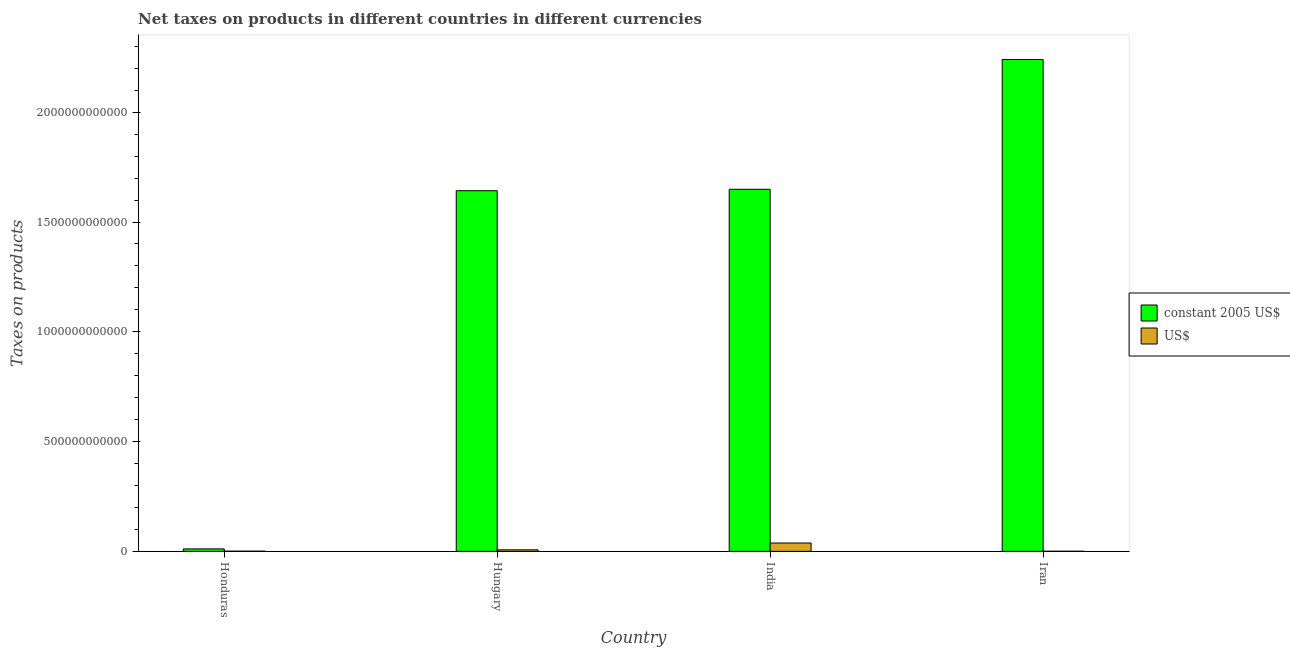How many bars are there on the 2nd tick from the left?
Your answer should be very brief. 2. What is the label of the 2nd group of bars from the left?
Provide a short and direct response. Hungary. What is the net taxes in constant 2005 us$ in Honduras?
Give a very brief answer. 1.12e+1. Across all countries, what is the maximum net taxes in us$?
Provide a short and direct response. 3.81e+1. Across all countries, what is the minimum net taxes in constant 2005 us$?
Offer a terse response. 1.12e+1. In which country was the net taxes in constant 2005 us$ maximum?
Give a very brief answer. Iran. In which country was the net taxes in us$ minimum?
Your answer should be compact. Iran. What is the total net taxes in us$ in the graph?
Your answer should be compact. 4.63e+1. What is the difference between the net taxes in us$ in India and that in Iran?
Offer a very short reply. 3.75e+1. What is the difference between the net taxes in us$ in Iran and the net taxes in constant 2005 us$ in Hungary?
Your response must be concise. -1.64e+12. What is the average net taxes in constant 2005 us$ per country?
Keep it short and to the point. 1.39e+12. What is the difference between the net taxes in us$ and net taxes in constant 2005 us$ in Iran?
Your response must be concise. -2.24e+12. What is the ratio of the net taxes in us$ in Hungary to that in India?
Offer a terse response. 0.18. Is the net taxes in us$ in Honduras less than that in Hungary?
Keep it short and to the point. Yes. What is the difference between the highest and the second highest net taxes in constant 2005 us$?
Offer a very short reply. 5.91e+11. What is the difference between the highest and the lowest net taxes in us$?
Make the answer very short. 3.75e+1. In how many countries, is the net taxes in us$ greater than the average net taxes in us$ taken over all countries?
Provide a succinct answer. 1. What does the 1st bar from the left in Iran represents?
Provide a short and direct response. Constant 2005 us$. What does the 2nd bar from the right in Honduras represents?
Ensure brevity in your answer.  Constant 2005 us$. Are all the bars in the graph horizontal?
Your response must be concise. No. What is the difference between two consecutive major ticks on the Y-axis?
Give a very brief answer. 5.00e+11. Are the values on the major ticks of Y-axis written in scientific E-notation?
Your response must be concise. No. Does the graph contain any zero values?
Offer a terse response. No. Where does the legend appear in the graph?
Offer a terse response. Center right. How many legend labels are there?
Your response must be concise. 2. How are the legend labels stacked?
Keep it short and to the point. Vertical. What is the title of the graph?
Make the answer very short. Net taxes on products in different countries in different currencies. What is the label or title of the X-axis?
Offer a terse response. Country. What is the label or title of the Y-axis?
Your response must be concise. Taxes on products. What is the Taxes on products of constant 2005 US$ in Honduras?
Your answer should be very brief. 1.12e+1. What is the Taxes on products of US$ in Honduras?
Provide a short and direct response. 7.81e+08. What is the Taxes on products in constant 2005 US$ in Hungary?
Offer a very short reply. 1.64e+12. What is the Taxes on products in US$ in Hungary?
Provide a succinct answer. 6.93e+09. What is the Taxes on products of constant 2005 US$ in India?
Your answer should be very brief. 1.65e+12. What is the Taxes on products of US$ in India?
Keep it short and to the point. 3.81e+1. What is the Taxes on products of constant 2005 US$ in Iran?
Keep it short and to the point. 2.24e+12. What is the Taxes on products in US$ in Iran?
Your answer should be compact. 5.37e+08. Across all countries, what is the maximum Taxes on products of constant 2005 US$?
Your answer should be very brief. 2.24e+12. Across all countries, what is the maximum Taxes on products of US$?
Provide a succinct answer. 3.81e+1. Across all countries, what is the minimum Taxes on products of constant 2005 US$?
Keep it short and to the point. 1.12e+1. Across all countries, what is the minimum Taxes on products of US$?
Your answer should be compact. 5.37e+08. What is the total Taxes on products in constant 2005 US$ in the graph?
Provide a succinct answer. 5.54e+12. What is the total Taxes on products of US$ in the graph?
Keep it short and to the point. 4.63e+1. What is the difference between the Taxes on products of constant 2005 US$ in Honduras and that in Hungary?
Keep it short and to the point. -1.63e+12. What is the difference between the Taxes on products in US$ in Honduras and that in Hungary?
Make the answer very short. -6.15e+09. What is the difference between the Taxes on products of constant 2005 US$ in Honduras and that in India?
Make the answer very short. -1.64e+12. What is the difference between the Taxes on products of US$ in Honduras and that in India?
Give a very brief answer. -3.73e+1. What is the difference between the Taxes on products of constant 2005 US$ in Honduras and that in Iran?
Provide a succinct answer. -2.23e+12. What is the difference between the Taxes on products of US$ in Honduras and that in Iran?
Your answer should be compact. 2.44e+08. What is the difference between the Taxes on products in constant 2005 US$ in Hungary and that in India?
Ensure brevity in your answer.  -6.62e+09. What is the difference between the Taxes on products of US$ in Hungary and that in India?
Your answer should be compact. -3.11e+1. What is the difference between the Taxes on products of constant 2005 US$ in Hungary and that in Iran?
Your answer should be compact. -5.98e+11. What is the difference between the Taxes on products of US$ in Hungary and that in Iran?
Offer a very short reply. 6.39e+09. What is the difference between the Taxes on products in constant 2005 US$ in India and that in Iran?
Make the answer very short. -5.91e+11. What is the difference between the Taxes on products in US$ in India and that in Iran?
Provide a succinct answer. 3.75e+1. What is the difference between the Taxes on products in constant 2005 US$ in Honduras and the Taxes on products in US$ in Hungary?
Your response must be concise. 4.29e+09. What is the difference between the Taxes on products in constant 2005 US$ in Honduras and the Taxes on products in US$ in India?
Your answer should be very brief. -2.68e+1. What is the difference between the Taxes on products in constant 2005 US$ in Honduras and the Taxes on products in US$ in Iran?
Give a very brief answer. 1.07e+1. What is the difference between the Taxes on products of constant 2005 US$ in Hungary and the Taxes on products of US$ in India?
Ensure brevity in your answer.  1.60e+12. What is the difference between the Taxes on products in constant 2005 US$ in Hungary and the Taxes on products in US$ in Iran?
Ensure brevity in your answer.  1.64e+12. What is the difference between the Taxes on products in constant 2005 US$ in India and the Taxes on products in US$ in Iran?
Your response must be concise. 1.65e+12. What is the average Taxes on products in constant 2005 US$ per country?
Your answer should be very brief. 1.39e+12. What is the average Taxes on products in US$ per country?
Keep it short and to the point. 1.16e+1. What is the difference between the Taxes on products of constant 2005 US$ and Taxes on products of US$ in Honduras?
Give a very brief answer. 1.04e+1. What is the difference between the Taxes on products in constant 2005 US$ and Taxes on products in US$ in Hungary?
Ensure brevity in your answer.  1.64e+12. What is the difference between the Taxes on products of constant 2005 US$ and Taxes on products of US$ in India?
Give a very brief answer. 1.61e+12. What is the difference between the Taxes on products of constant 2005 US$ and Taxes on products of US$ in Iran?
Your answer should be very brief. 2.24e+12. What is the ratio of the Taxes on products in constant 2005 US$ in Honduras to that in Hungary?
Your answer should be compact. 0.01. What is the ratio of the Taxes on products of US$ in Honduras to that in Hungary?
Your response must be concise. 0.11. What is the ratio of the Taxes on products in constant 2005 US$ in Honduras to that in India?
Your response must be concise. 0.01. What is the ratio of the Taxes on products in US$ in Honduras to that in India?
Make the answer very short. 0.02. What is the ratio of the Taxes on products in constant 2005 US$ in Honduras to that in Iran?
Provide a succinct answer. 0.01. What is the ratio of the Taxes on products in US$ in Honduras to that in Iran?
Keep it short and to the point. 1.46. What is the ratio of the Taxes on products of constant 2005 US$ in Hungary to that in India?
Give a very brief answer. 1. What is the ratio of the Taxes on products in US$ in Hungary to that in India?
Give a very brief answer. 0.18. What is the ratio of the Taxes on products of constant 2005 US$ in Hungary to that in Iran?
Offer a terse response. 0.73. What is the ratio of the Taxes on products of US$ in Hungary to that in Iran?
Make the answer very short. 12.9. What is the ratio of the Taxes on products of constant 2005 US$ in India to that in Iran?
Make the answer very short. 0.74. What is the ratio of the Taxes on products in US$ in India to that in Iran?
Offer a very short reply. 70.87. What is the difference between the highest and the second highest Taxes on products of constant 2005 US$?
Provide a short and direct response. 5.91e+11. What is the difference between the highest and the second highest Taxes on products of US$?
Your answer should be compact. 3.11e+1. What is the difference between the highest and the lowest Taxes on products of constant 2005 US$?
Provide a succinct answer. 2.23e+12. What is the difference between the highest and the lowest Taxes on products in US$?
Keep it short and to the point. 3.75e+1. 